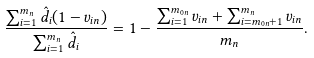Convert formula to latex. <formula><loc_0><loc_0><loc_500><loc_500>\frac { \sum _ { i = 1 } ^ { m _ { n } } \hat { d } _ { i } ( 1 - v _ { i n } ) } { \sum _ { i = 1 } ^ { m _ { n } } \hat { d } _ { i } } = 1 - \frac { \sum _ { i = 1 } ^ { m _ { 0 n } } v _ { i n } + \sum _ { i = m _ { 0 n } + 1 } ^ { m _ { n } } v _ { i n } } { m _ { n } } .</formula> 